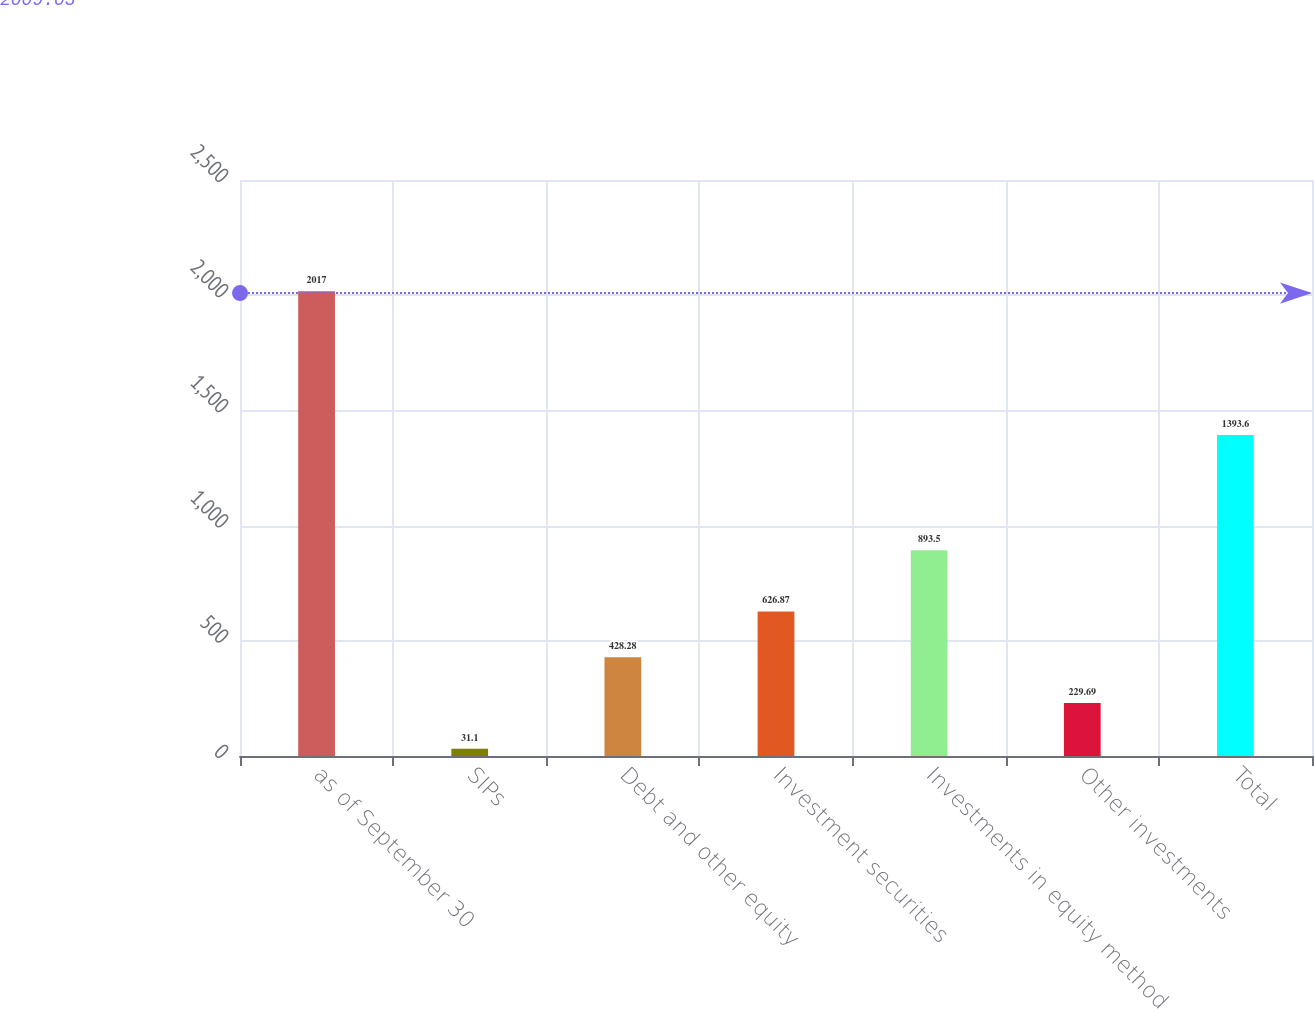Convert chart. <chart><loc_0><loc_0><loc_500><loc_500><bar_chart><fcel>as of September 30<fcel>SIPs<fcel>Debt and other equity<fcel>Investment securities<fcel>Investments in equity method<fcel>Other investments<fcel>Total<nl><fcel>2017<fcel>31.1<fcel>428.28<fcel>626.87<fcel>893.5<fcel>229.69<fcel>1393.6<nl></chart> 